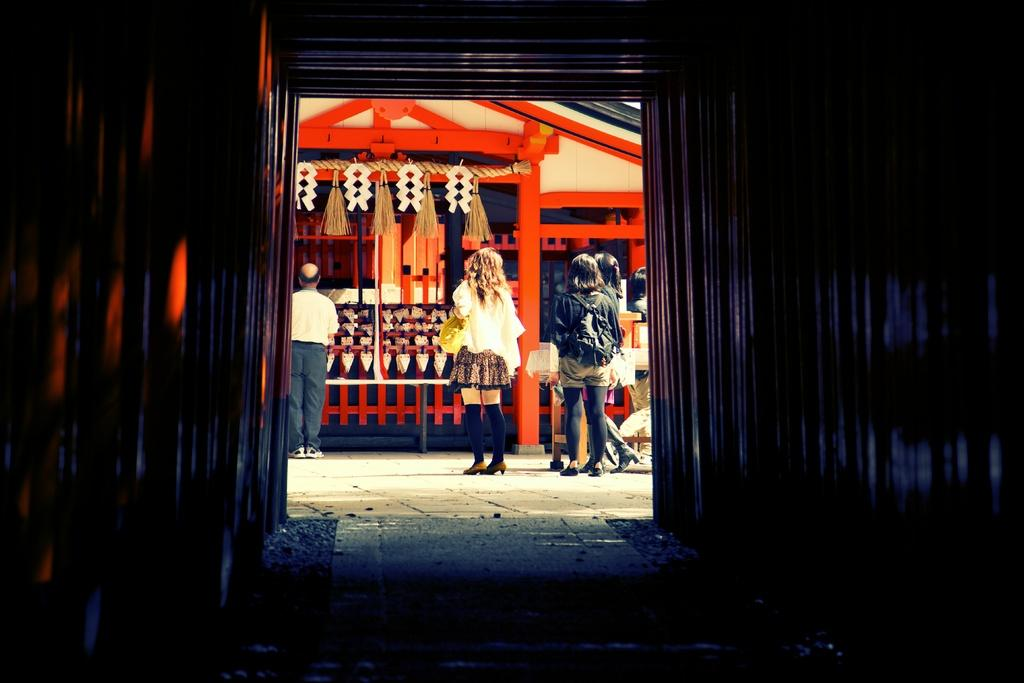What type of structure can be seen in the image? There are walls in the image, which suggests a structure of some kind. Can you describe the people in the image? There are people in the image, but their specific actions or characteristics are not mentioned in the provided facts. What other object can be seen in the image? There is a pole in the image. What color is the silver nose of the person in the image? There is no mention of a silver nose or any specific person in the image, so this detail cannot be confirmed. 